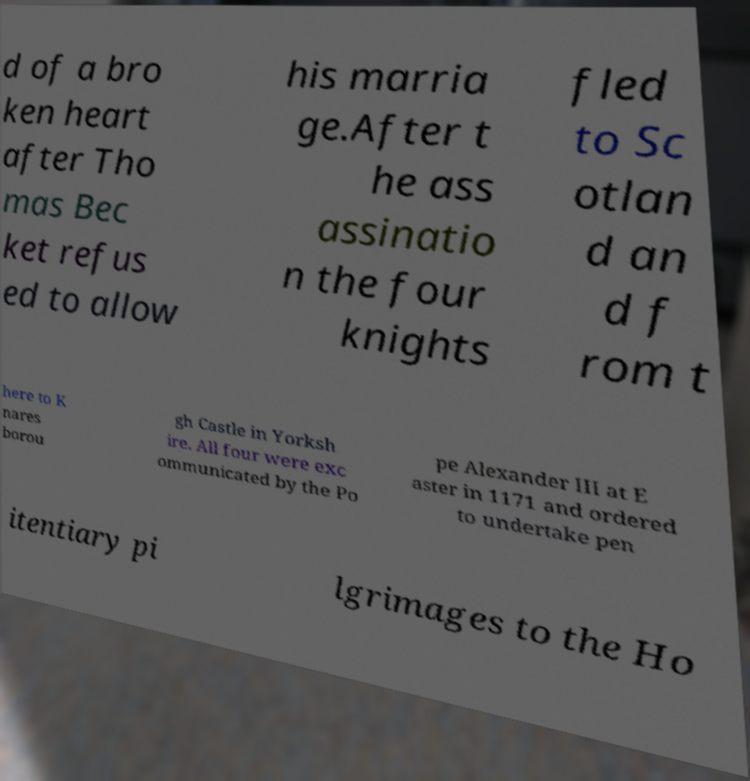Can you read and provide the text displayed in the image?This photo seems to have some interesting text. Can you extract and type it out for me? d of a bro ken heart after Tho mas Bec ket refus ed to allow his marria ge.After t he ass assinatio n the four knights fled to Sc otlan d an d f rom t here to K nares borou gh Castle in Yorksh ire. All four were exc ommunicated by the Po pe Alexander III at E aster in 1171 and ordered to undertake pen itentiary pi lgrimages to the Ho 